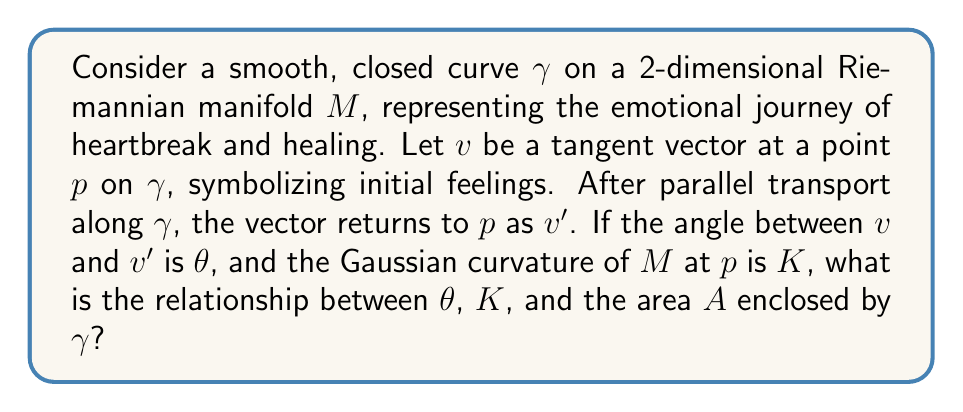Give your solution to this math problem. Let's approach this step-by-step:

1) The relationship we're looking for is given by the Gauss-Bonnet theorem for parallel transport. This theorem relates the holonomy of parallel transport around a closed curve to the integral of the Gaussian curvature over the region enclosed by the curve.

2) In our case, the holonomy is represented by the angle $\theta$ between the initial vector $v$ and the transported vector $v'$.

3) The Gauss-Bonnet theorem for parallel transport states:

   $$\theta = \int\int_D K dA$$

   where $D$ is the region enclosed by $\gamma$, $K$ is the Gaussian curvature, and $dA$ is the area element.

4) If we assume that the Gaussian curvature $K$ is constant over the enclosed region (which is a simplification of the emotional landscape), we can simplify this to:

   $$\theta = K \cdot A$$

   where $A$ is the total area enclosed by $\gamma$.

5) This equation represents how the "twisting" of the emotional space (represented by $K$) over the course of the journey (represented by $A$) results in a change in perspective (represented by $\theta$).

6) It's worth noting that if $K = 0$ (flat emotional space), then $\theta = 0$, meaning the initial and final emotional states would be identical, regardless of the journey taken.

7) Conversely, a non-zero $K$ implies that the journey through heartbreak and healing inevitably changes one's emotional perspective, even if you end up at the same point where you started.
Answer: $\theta = K \cdot A$ 